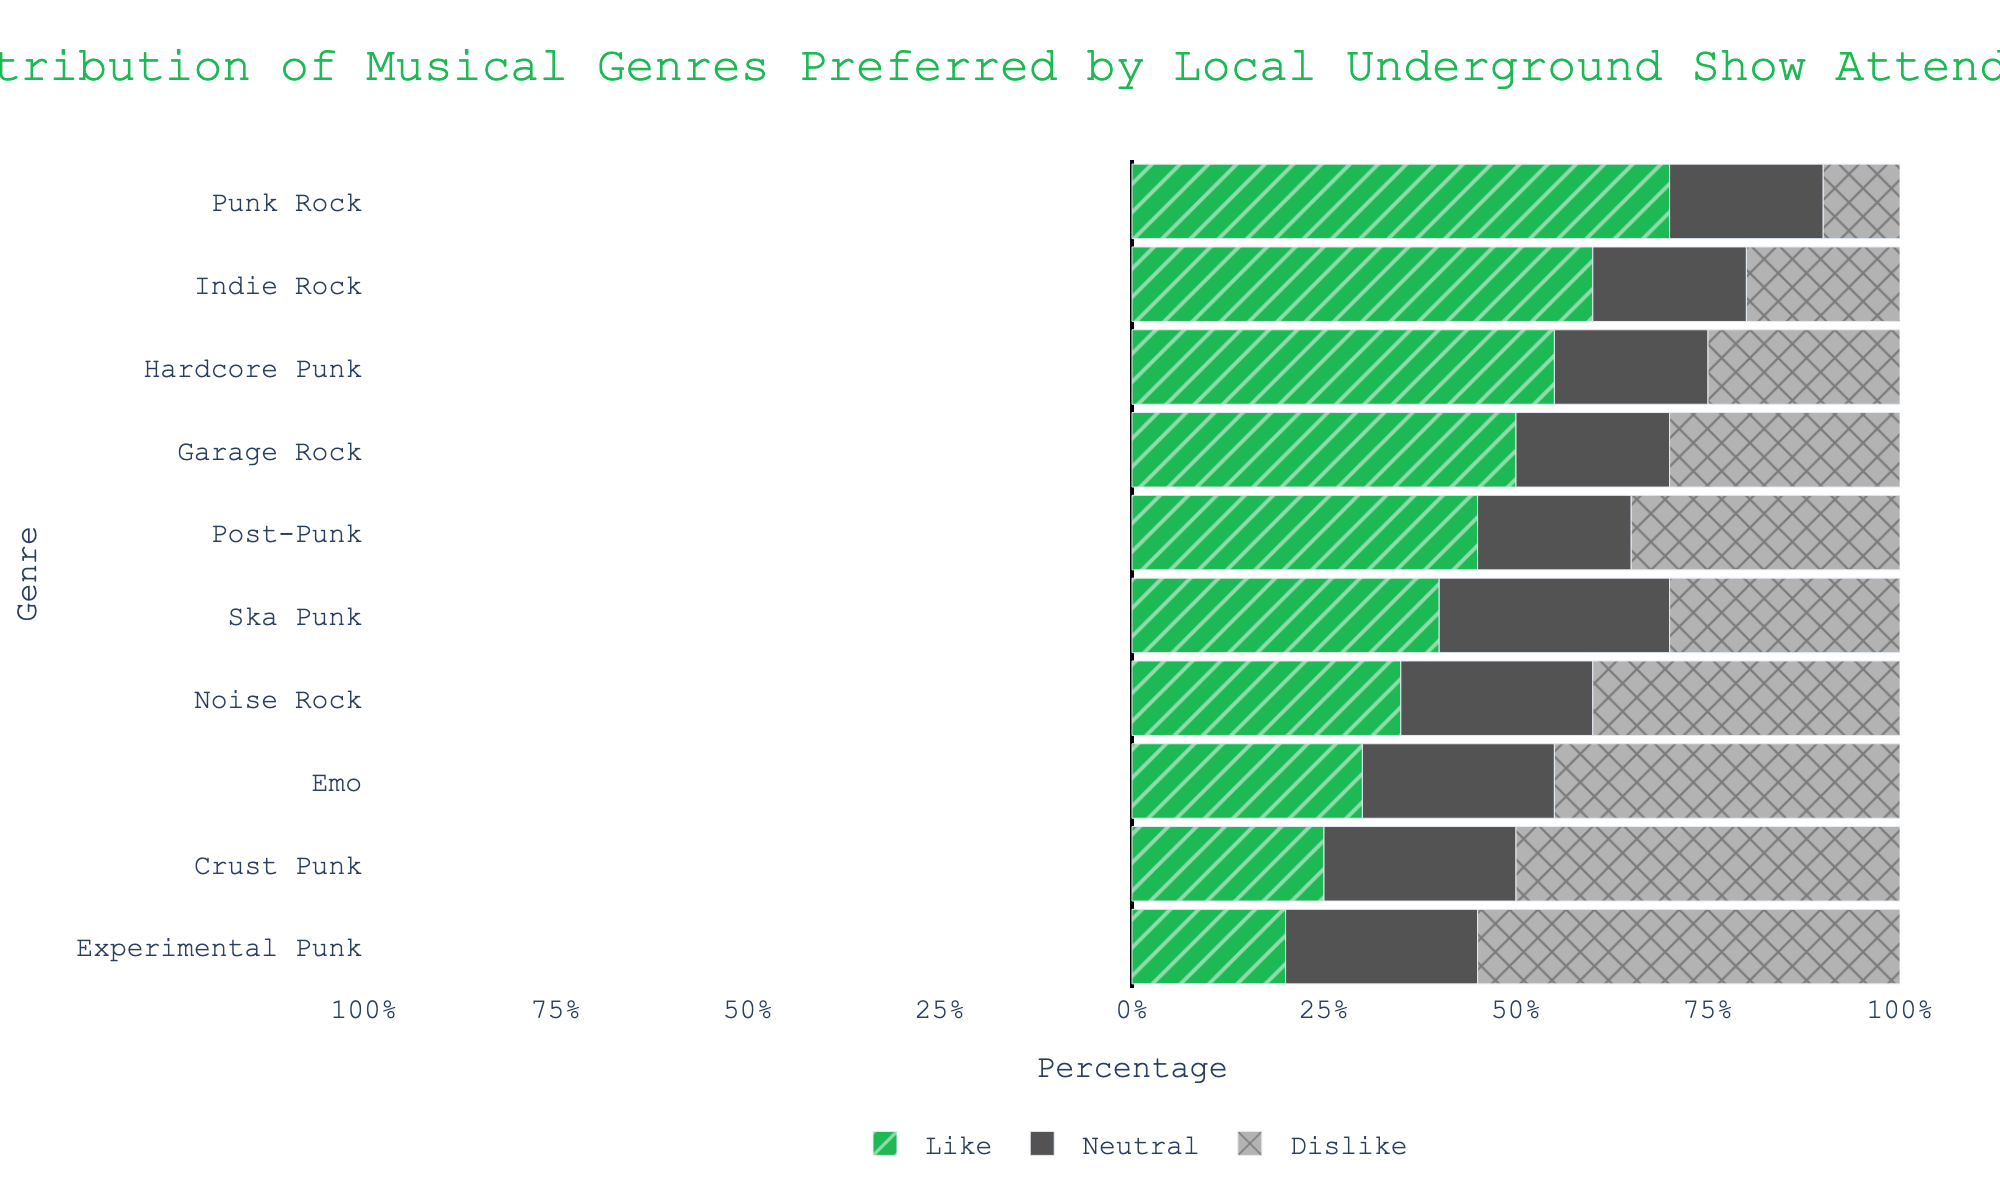What's the most liked genre? The bar representing "Punk Rock" is the longest in the 'Like' section, indicating that 70% of attendees like it.
Answer: Punk Rock Which genre has the highest percentage of dislike? "Experimental Punk" has the longest bar in the 'Dislike' section, showing that 55% of attendees dislike it.
Answer: Experimental Punk How much more do attendees prefer Indie Rock compared to Crust Punk? Indie Rock is liked by 60% of attendees, whereas Crust Punk is liked by 25%. The difference in preference is 60% - 25% = 35%.
Answer: 35% Which genre has the smallest difference between like and dislike percentages? For each genre, we calculate the absolute difference between the 'Like' and 'Dislike' percentages and find the smallest difference. "Ska Punk" has a like percentage of 40% and dislike percentage of 30%, so the difference is abs(40% - 30%) = 10%, which is the smallest.
Answer: Ska Punk In which genre do more people feel neutral? Neutral is calculated as 100% - Like% - Dislike%. "Punk Rock" has 100% - 70% - 10% = 20%, "Indie Rock" has 100% - 60% - 20% = 20%, and "Hardcore Punk" has 100% - 55% - 25% = 20%. The highest calculated neutral percentages are 20%, experienced by Punk Rock, Indie Rock, and Hardcore Punk.
Answer: Punk Rock, Indie Rock, Hardcore Punk Which genre has a higher percentage of likes, Garage Rock or Hardcore Punk? The 'Like' bar for Garage Rock is at 50%, while for Hardcore Punk it is at 55%. Compared side-by-side, Hardcore Punk has a higher percentage of likes.
Answer: Hardcore Punk What is the total percentage of attendees who like either Noise Rock or Emo? Noise Rock is liked by 35% of attendees, and Emo is liked by 30%. Summing these values gives 35% + 30% = 65%.
Answer: 65% How does the like percentage for Post-Punk compare to the dislike percentage for Crust Punk? The 'Like' percentage for Post-Punk is 45%, and the 'Dislike' percentage for Crust Punk is 50%. Comparing these, Post-Punk's 'Like' is 5% less than Crust Punk's 'Dislike'.
Answer: 5% less What percentage of attendees dislike Punk Rock? According to the chart, 10% of the attendees dislike Punk Rock.
Answer: 10% What is the combined percentage of attendees who either like or dislike Noise Rock? The 'Like' percentage for Noise Rock is 35%, and the 'Dislike' percentage is 40%. Summing these gives 35% + 40% = 75%.
Answer: 75% 